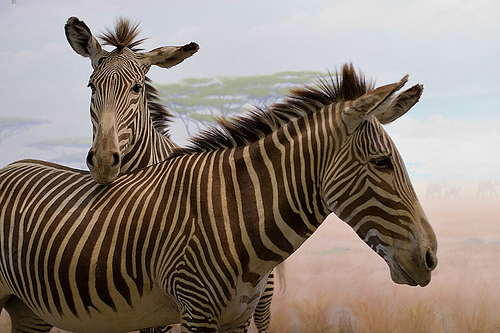Can you explain the significance of the zebra's stripe pattern in their natural habitat? Zebra stripes serve multiple ecological purposes; primarily, they create optical illusions that confuse predators both at a distance and up-close, and are thought to play a role in social interactions among zebras themselves. 